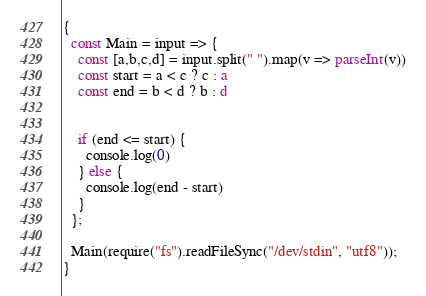Convert code to text. <code><loc_0><loc_0><loc_500><loc_500><_TypeScript_>{
  const Main = input => {
    const [a,b,c,d] = input.split(" ").map(v => parseInt(v))
    const start = a < c ? c : a
    const end = b < d ? b : d


    if (end <= start) {
      console.log(0)
    } else {
      console.log(end - start)
    }
  };

  Main(require("fs").readFileSync("/dev/stdin", "utf8"));
}
</code> 